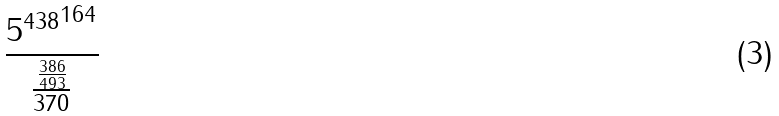<formula> <loc_0><loc_0><loc_500><loc_500>\frac { { 5 ^ { 4 3 8 } } ^ { 1 6 4 } } { \frac { \frac { 3 8 6 } { 4 9 3 } } { 3 7 0 } }</formula> 